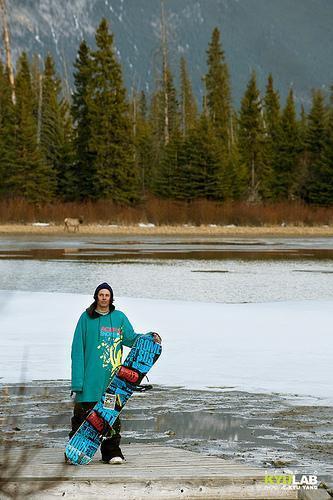How many people are there?
Give a very brief answer. 1. 